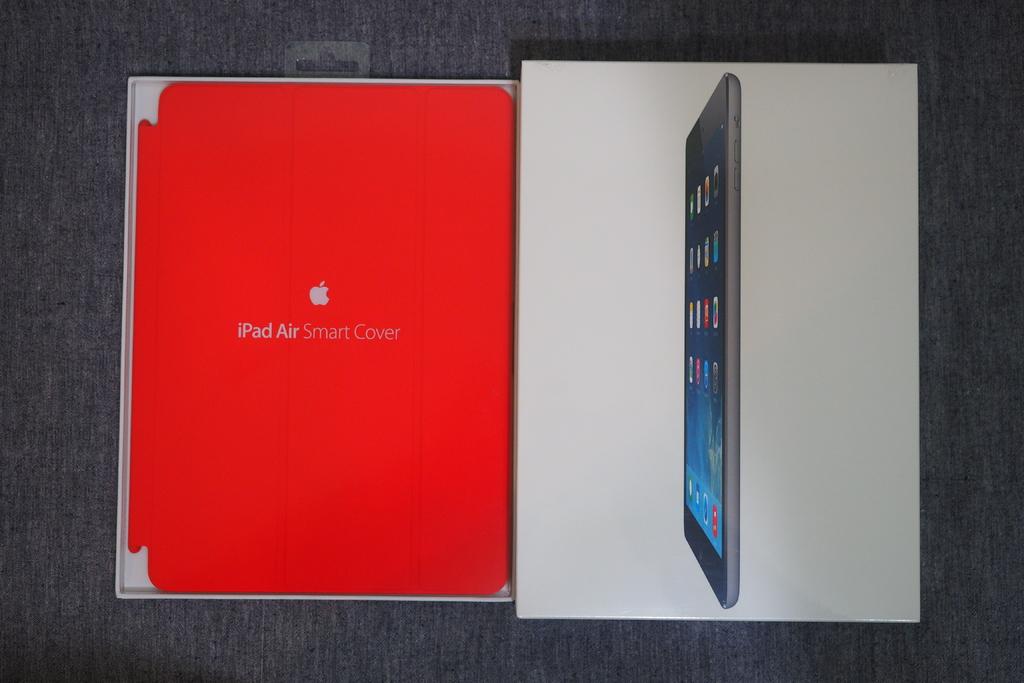What is this?
Your answer should be very brief. Ipad air. 